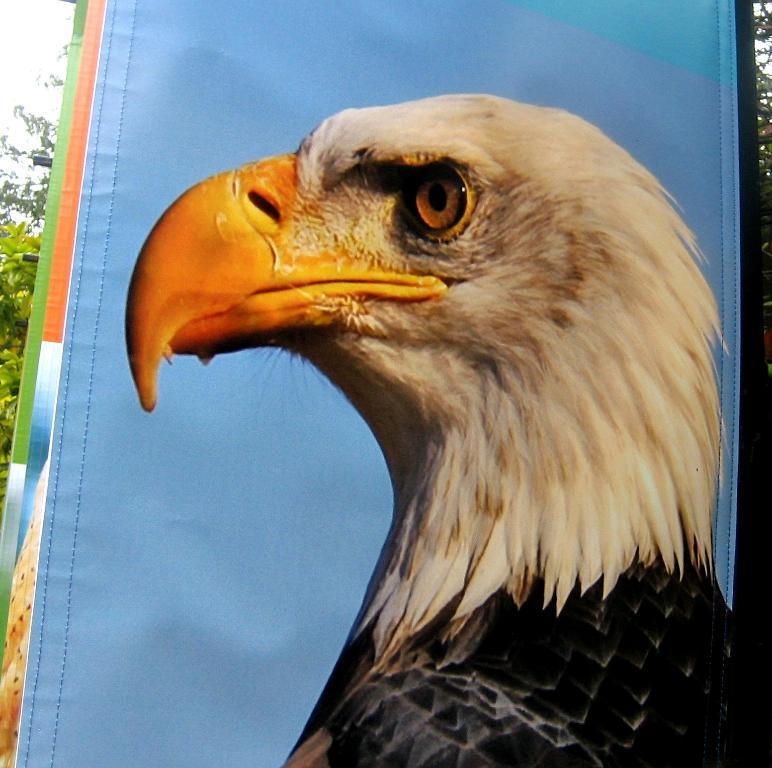In one or two sentences, can you explain what this image depicts? The picture consists of a banner. In the banner there is an eagle, behind the banner there are trees. 